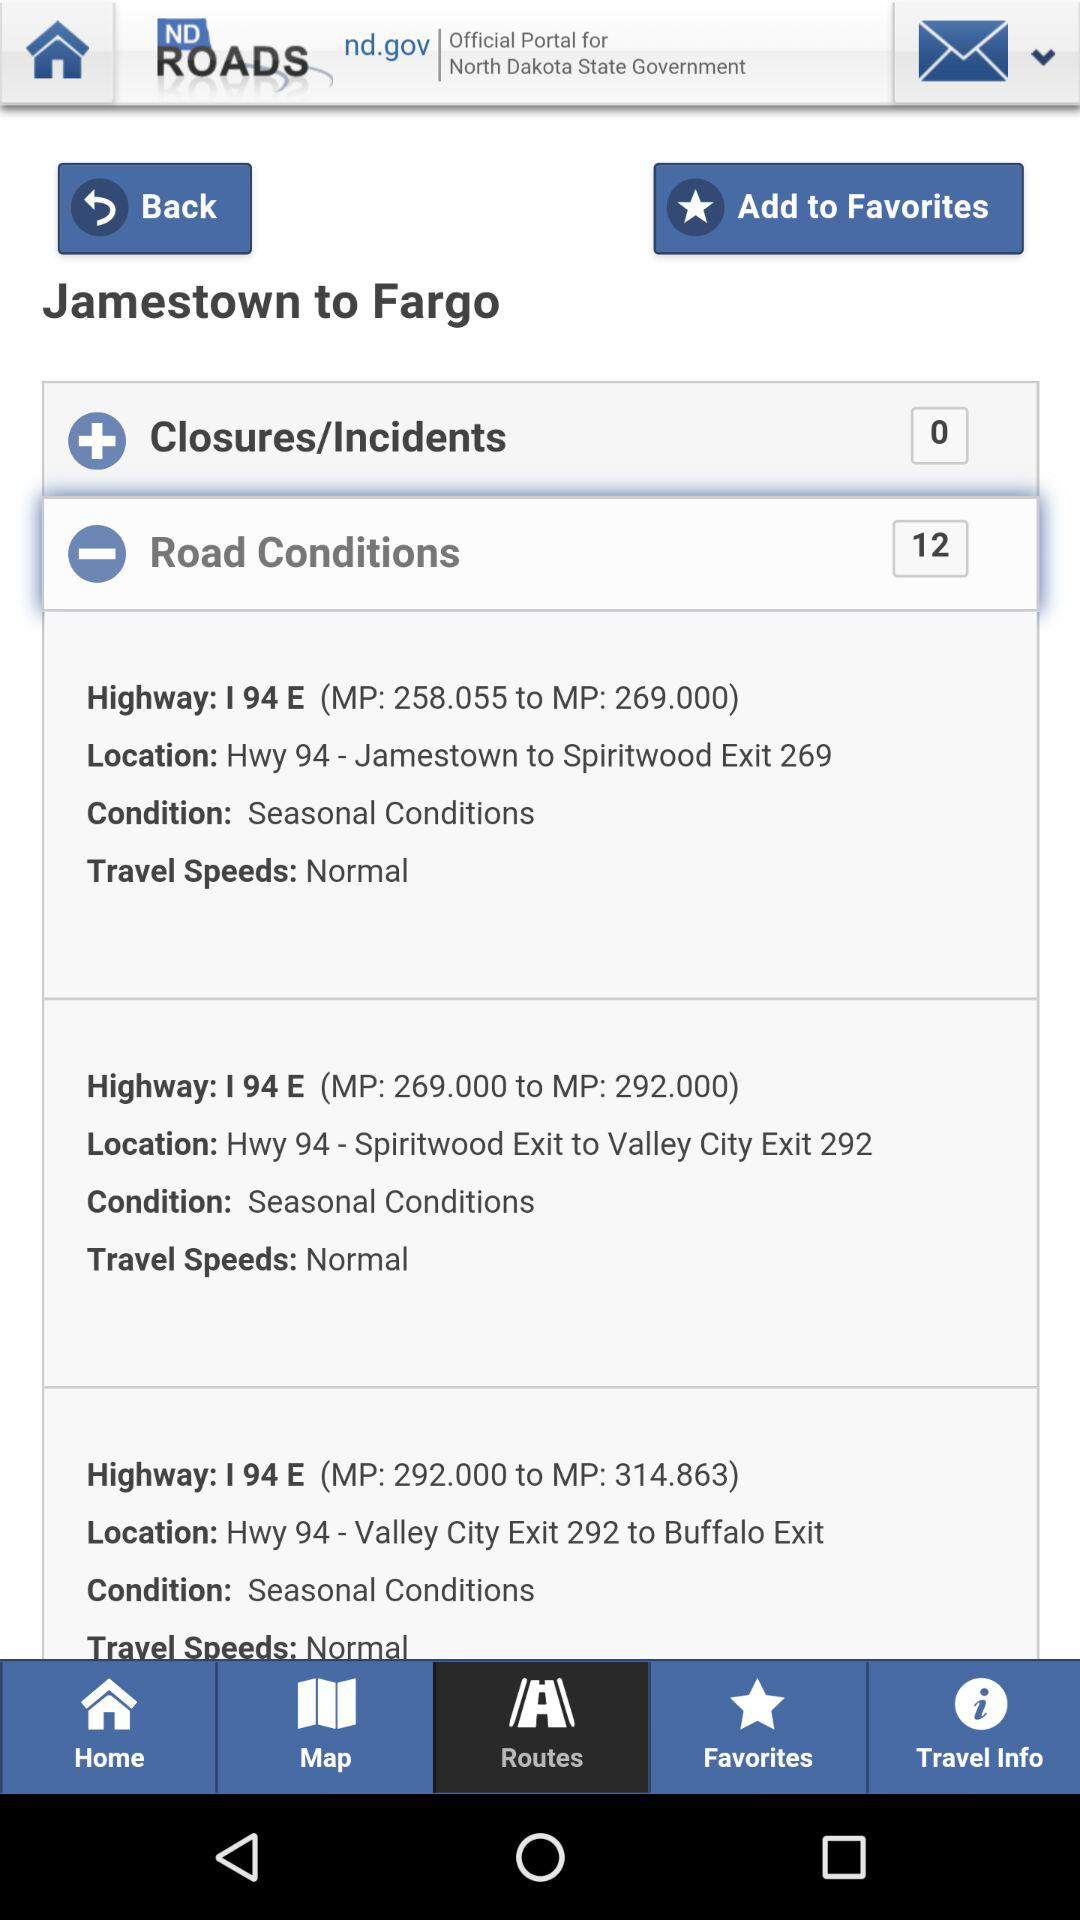Where is it from? It is from Jamestown. 